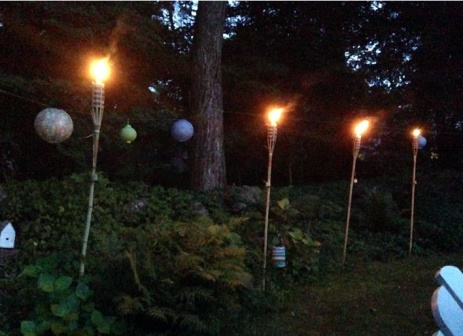What kind of event or occasion might this setup be for? The setup in the image appears to be ideal for an intimate outdoor gathering or celebration. The warm glow of the tiki torches and the soft light of the paper lanterns create a cozy and welcoming ambiance, perfect for events such as a small garden party, a romantic dinner, or a serene evening of relaxation and conversation with friends. The careful arrangement of lighting and plants suggests a setting meant to foster relaxation and enjoyment of nature. 